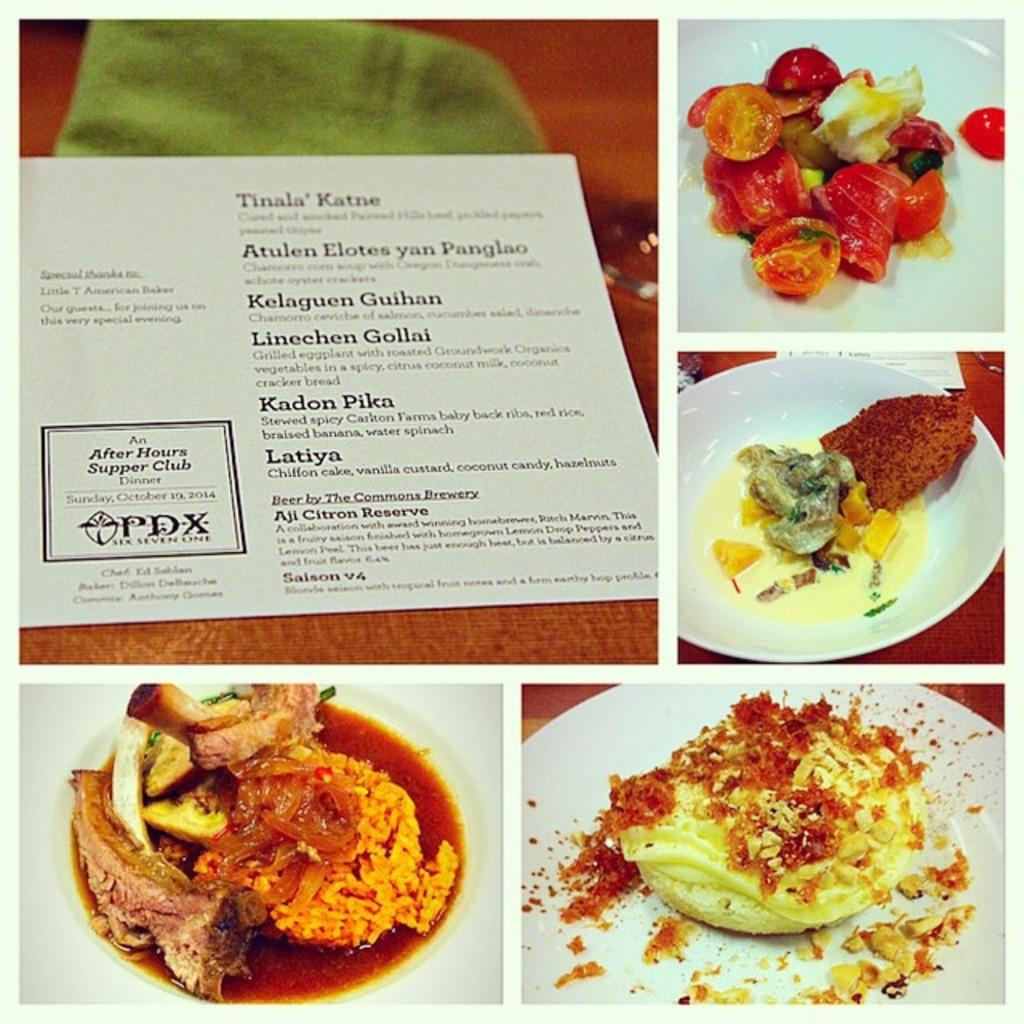What type of artwork is depicted in the image? The image is a collage. What material can be seen in the collage? There is a paper in the collage. What type of objects are featured on the plates in the collage? The plates in the collage have food on them. What type of marble is used as a background in the collage? There is no marble present in the collage; it is a paper-based artwork. How does the collage support the journey of the artist? The collage itself does not support a journey, as it is a static artwork. 